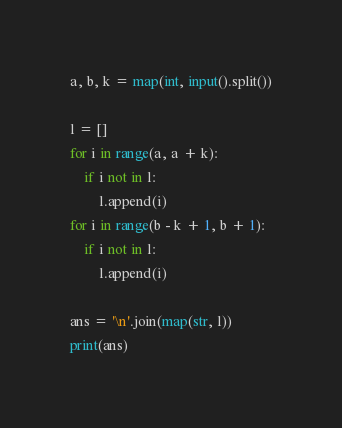<code> <loc_0><loc_0><loc_500><loc_500><_Python_>a, b, k = map(int, input().split())

l = []
for i in range(a, a + k):
    if i not in l:
        l.append(i)
for i in range(b - k + 1, b + 1):
    if i not in l:
        l.append(i)

ans = '\n'.join(map(str, l))
print(ans)

</code> 